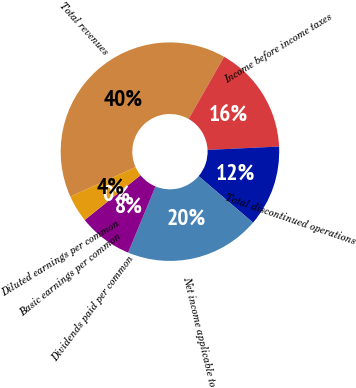Convert chart. <chart><loc_0><loc_0><loc_500><loc_500><pie_chart><fcel>Total revenues<fcel>Income before income taxes<fcel>Total discontinued operations<fcel>Net income applicable to<fcel>Dividends paid per common<fcel>Basic earnings per common<fcel>Diluted earnings per common<nl><fcel>40.0%<fcel>16.0%<fcel>12.0%<fcel>20.0%<fcel>8.0%<fcel>0.0%<fcel>4.0%<nl></chart> 